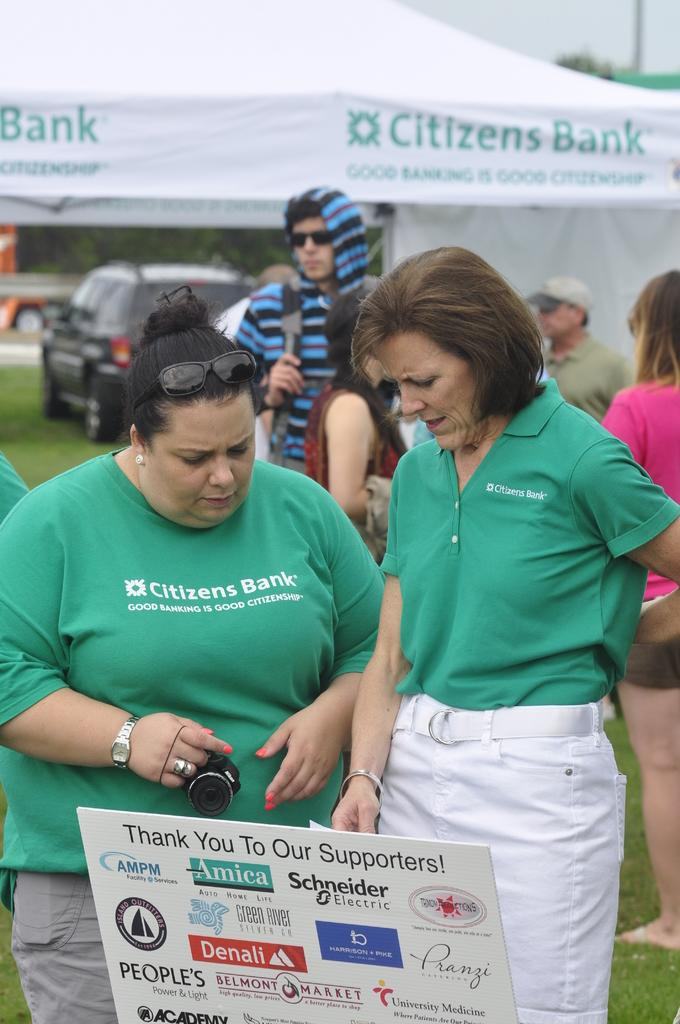How many people are in the image? There are persons in the image, but the exact number is not specified. What is the woman holding in the image? The woman is holding a camera in the image. What can be seen on the hoarding in the image? The content of the hoarding is not mentioned, but it is present in the image. What type of vegetation is visible in the image? There is grass in the image. What type of vehicle is in the image? There is a car in the image. What type of temporary shelter is in the image? There is a tent in the image. What is visible in the background of the image? The sky is visible in the background of the image. What type of protest is taking place in the image? There is no protest present in the image. Is the governor attending the church service in the image? There is no church or governor mentioned in the image. 